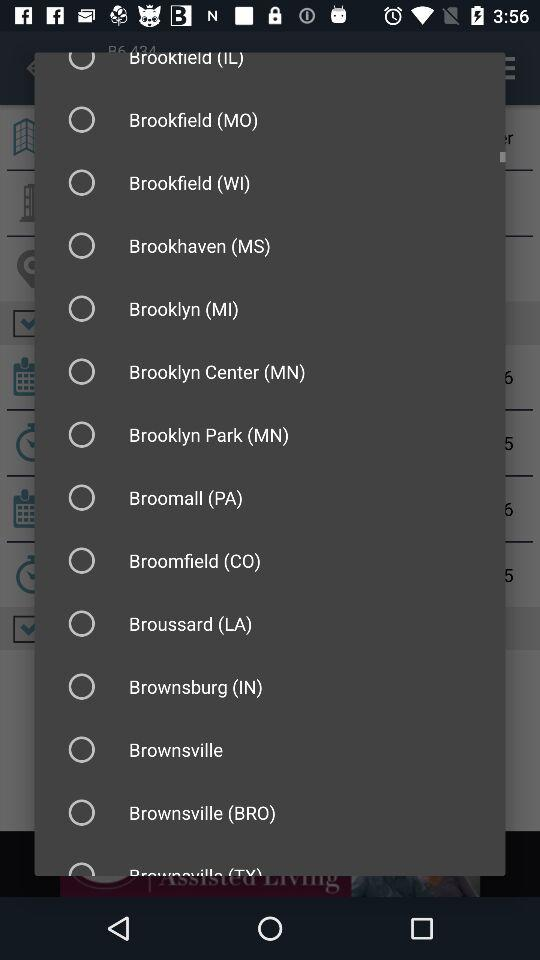Which year is selected? The selected year is 2016. 